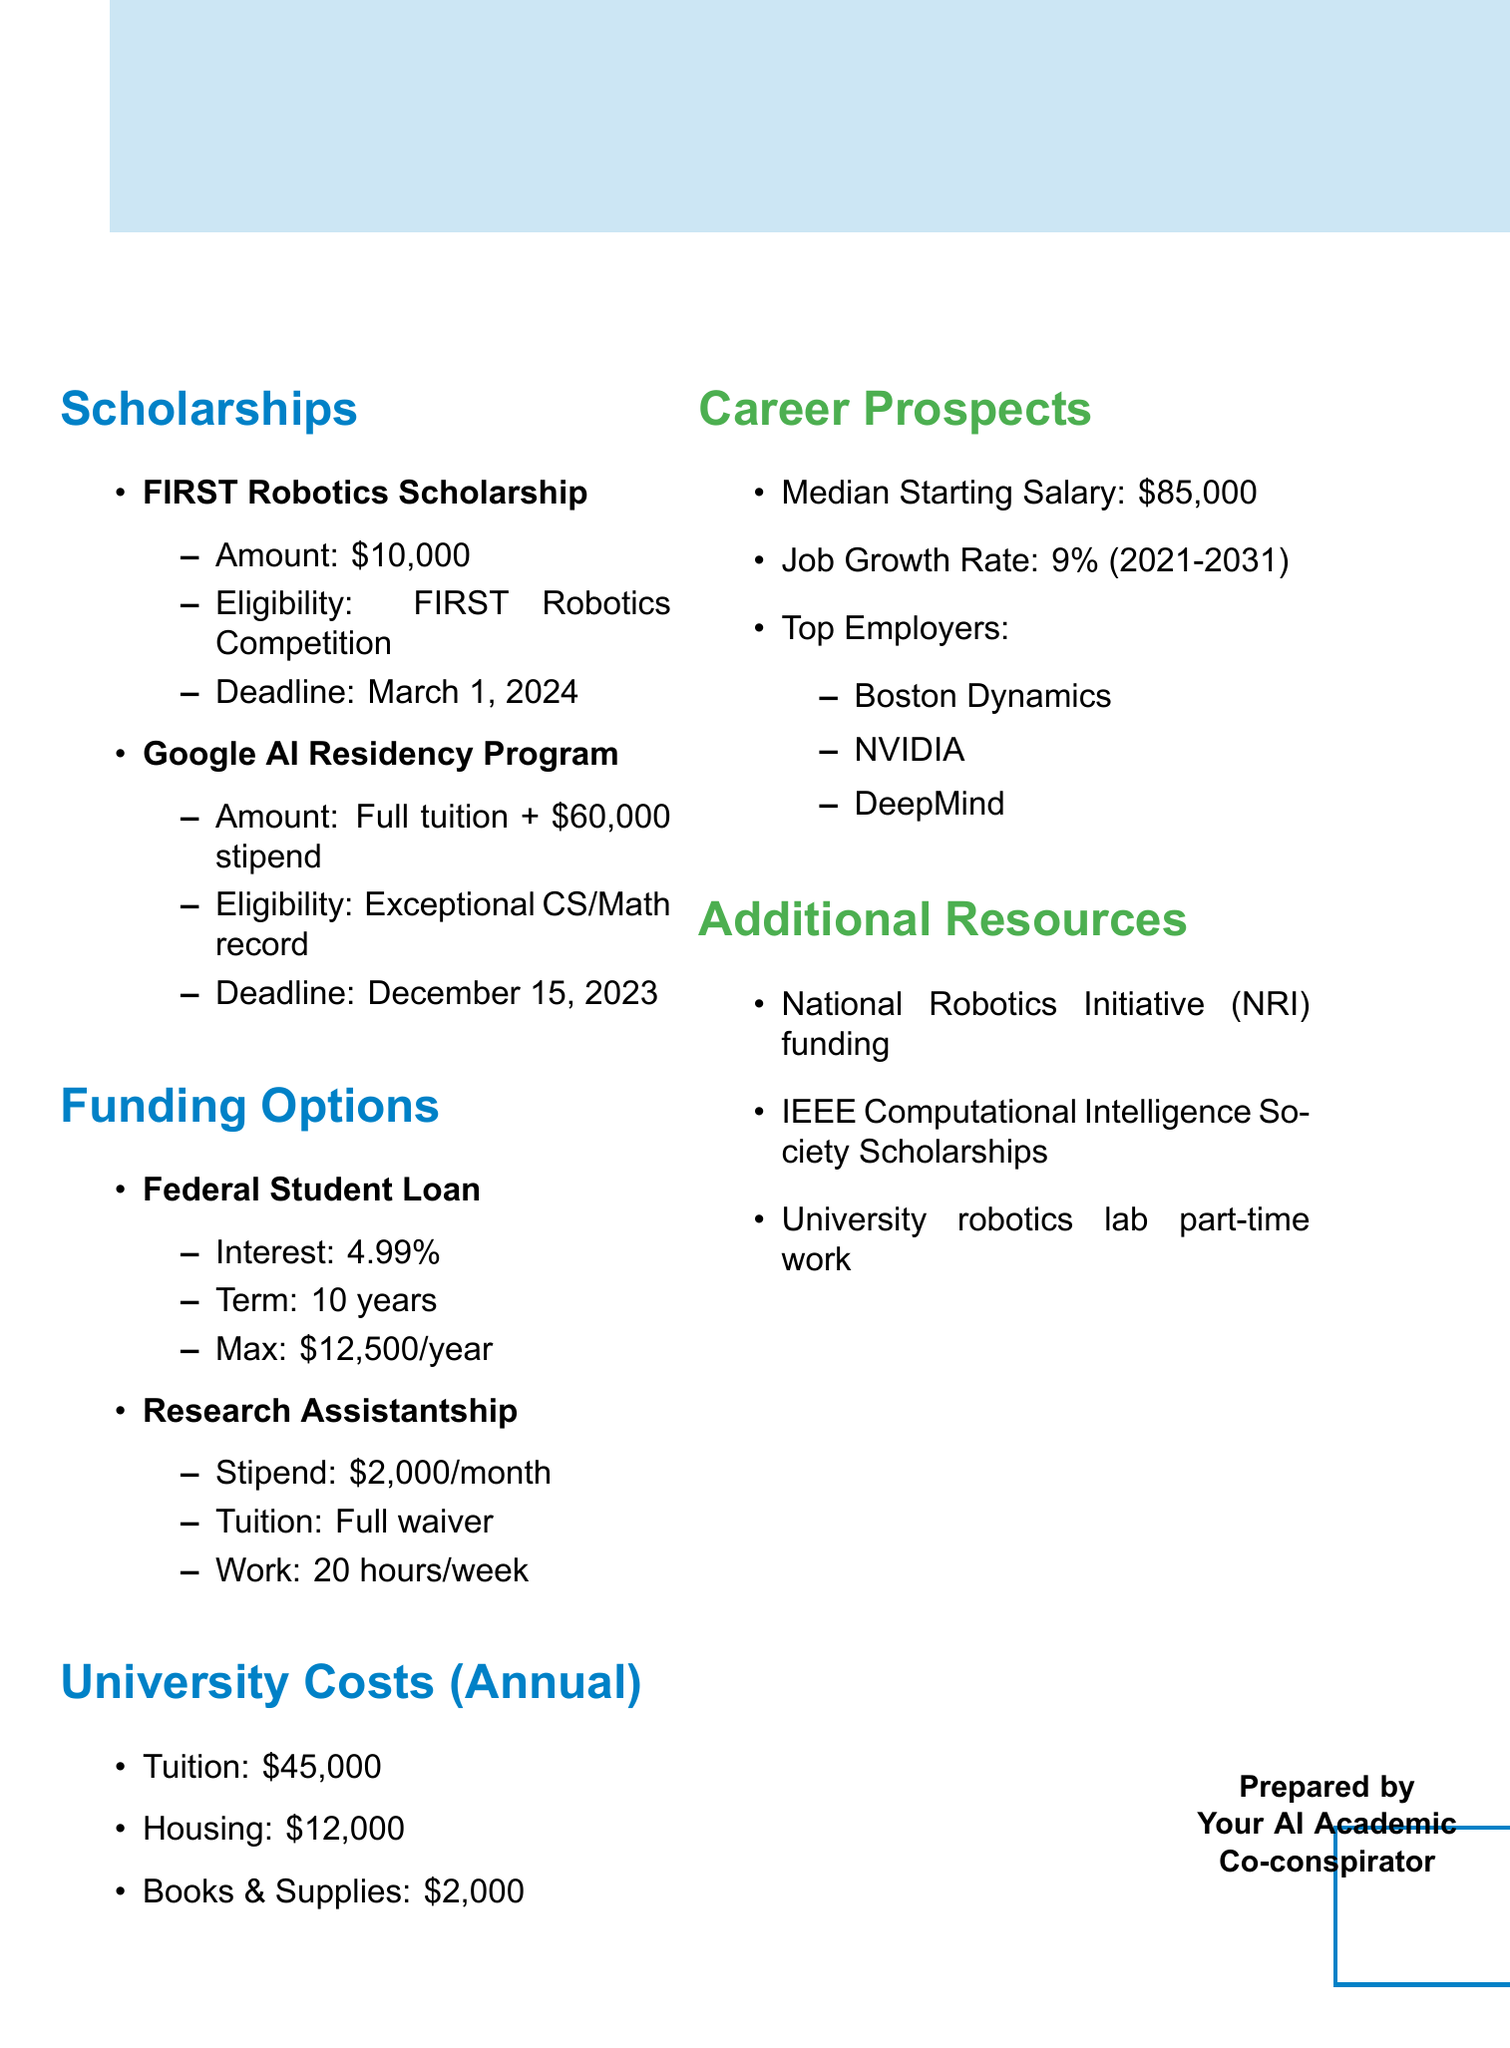What is the amount of the FIRST Robotics Scholarship? The document states that the FIRST Robotics Scholarship offers an amount of $10,000.
Answer: $10,000 When is the deadline for the Google AI Residency Program? According to the document, the deadline for the Google AI Residency Program is December 15, 2023.
Answer: December 15, 2023 What is the maximum amount available for a Federal Student Loan per year? The document indicates that the maximum amount for a Federal Student Loan is $12,500 per year.
Answer: $12,500 per year What is the median starting salary for graduates in robotics and AI? The document provides the median starting salary as $85,000.
Answer: $85,000 How many hours per week is a Research Assistantship expected to work? The document specifies that a Research Assistantship requires working 20 hours per week.
Answer: 20 hours per week What total annual cost does tuition, housing, and supplies amount to? The total is calculated as $45,000 (tuition) + $12,000 (housing) + $2,000 (supplies) = $59,000.
Answer: $59,000 What job growth rate is projected from 2021 to 2031? The document states that the job growth rate is 9% from 2021 to 2031.
Answer: 9% Which organization provides additional funding opportunities mentioned in the document? The National Robotics Initiative (NRI) is mentioned as a source of additional funding opportunities.
Answer: National Robotics Initiative (NRI) 